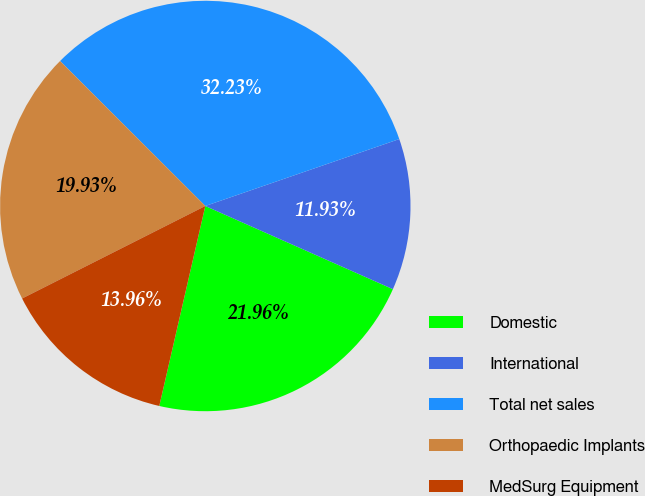Convert chart to OTSL. <chart><loc_0><loc_0><loc_500><loc_500><pie_chart><fcel>Domestic<fcel>International<fcel>Total net sales<fcel>Orthopaedic Implants<fcel>MedSurg Equipment<nl><fcel>21.96%<fcel>11.93%<fcel>32.23%<fcel>19.93%<fcel>13.96%<nl></chart> 